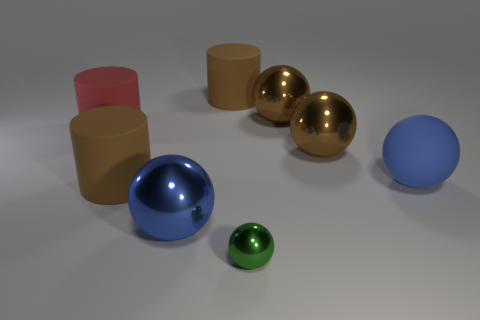Subtract 2 balls. How many balls are left? 3 Subtract all green balls. How many balls are left? 4 Subtract all blue rubber spheres. How many spheres are left? 4 Subtract all gray balls. Subtract all blue cylinders. How many balls are left? 5 Add 2 green spheres. How many objects exist? 10 Subtract all cylinders. How many objects are left? 5 Add 1 blue matte balls. How many blue matte balls are left? 2 Add 7 cylinders. How many cylinders exist? 10 Subtract 0 gray spheres. How many objects are left? 8 Subtract all red matte objects. Subtract all large balls. How many objects are left? 3 